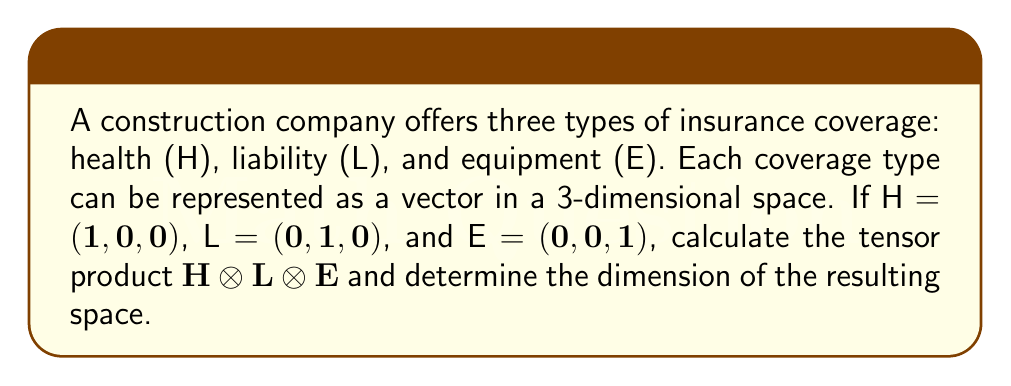Teach me how to tackle this problem. To solve this problem, we'll follow these steps:

1) First, recall that the tensor product of vectors creates a higher-dimensional space. The dimension of the resulting space is the product of the dimensions of the individual spaces.

2) Each of our vectors (H, L, E) is in $\mathbb{R}^3$, so the dimension of each individual space is 3.

3) The tensor product $H \otimes L \otimes E$ will result in a space with dimension:

   $\text{dim}(H \otimes L \otimes E) = \text{dim}(H) \cdot \text{dim}(L) \cdot \text{dim}(E) = 3 \cdot 3 \cdot 3 = 27$

4) To calculate the actual tensor product:

   $H \otimes L \otimes E = (1,0,0) \otimes (0,1,0) \otimes (0,0,1)$

5) This results in a 27-dimensional vector where all components are zero except for the component corresponding to the product of the non-zero entries from each vector. In this case, it's the 14th component (in 0-based indexing).

6) So, the result is a 27-dimensional vector with a 1 in the 14th position and 0 everywhere else.

7) We can represent this as:

   $(0,0,0,0,0,0,0,0,0,0,0,0,0,1,0,0,0,0,0,0,0,0,0,0,0,0,0)$

   Or more compactly as:

   $e_{14}$ in $\mathbb{R}^{27}$, where $e_{14}$ is the 14th standard basis vector.
Answer: $e_{14}$ in $\mathbb{R}^{27}$ 